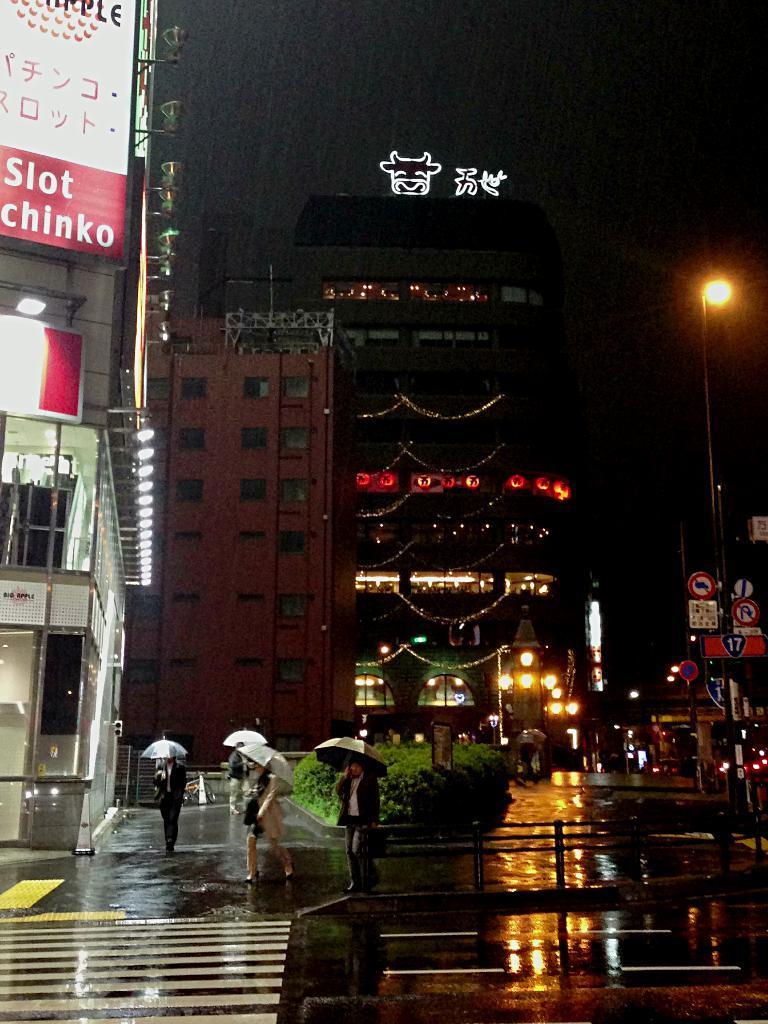Can you describe this image briefly? At the bottom of the image few people are walking and holding some umbrellas. Behind them we can see some plants, buildings, poles and sign boards. 